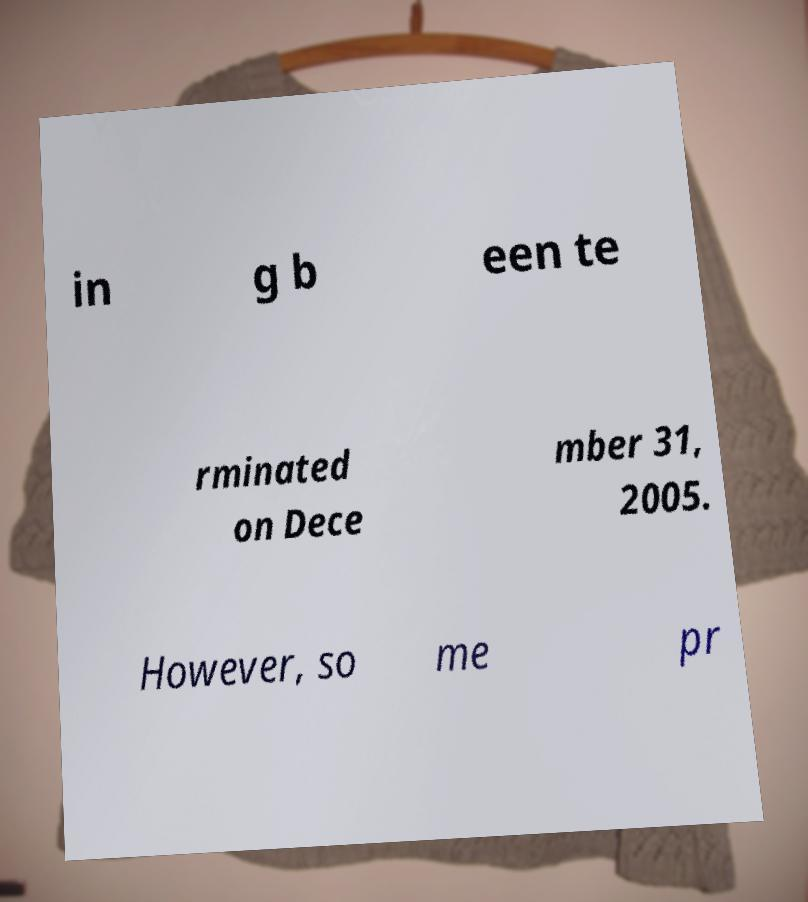Please read and relay the text visible in this image. What does it say? in g b een te rminated on Dece mber 31, 2005. However, so me pr 